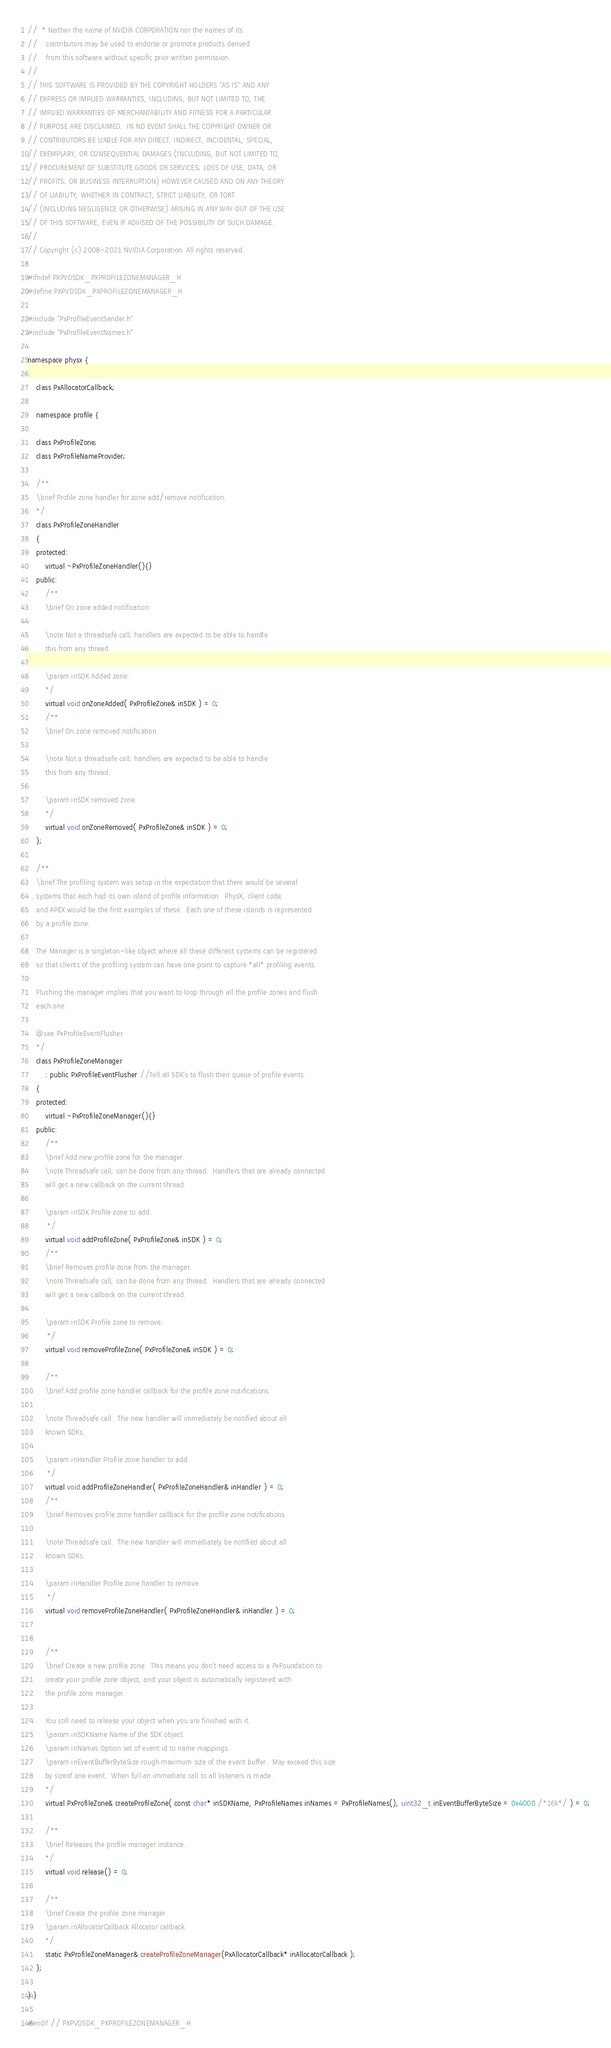<code> <loc_0><loc_0><loc_500><loc_500><_C_>//  * Neither the name of NVIDIA CORPORATION nor the names of its
//    contributors may be used to endorse or promote products derived
//    from this software without specific prior written permission.
//
// THIS SOFTWARE IS PROVIDED BY THE COPYRIGHT HOLDERS ''AS IS'' AND ANY
// EXPRESS OR IMPLIED WARRANTIES, INCLUDING, BUT NOT LIMITED TO, THE
// IMPLIED WARRANTIES OF MERCHANTABILITY AND FITNESS FOR A PARTICULAR
// PURPOSE ARE DISCLAIMED.  IN NO EVENT SHALL THE COPYRIGHT OWNER OR
// CONTRIBUTORS BE LIABLE FOR ANY DIRECT, INDIRECT, INCIDENTAL, SPECIAL,
// EXEMPLARY, OR CONSEQUENTIAL DAMAGES (INCLUDING, BUT NOT LIMITED TO,
// PROCUREMENT OF SUBSTITUTE GOODS OR SERVICES; LOSS OF USE, DATA, OR
// PROFITS; OR BUSINESS INTERRUPTION) HOWEVER CAUSED AND ON ANY THEORY
// OF LIABILITY, WHETHER IN CONTRACT, STRICT LIABILITY, OR TORT
// (INCLUDING NEGLIGENCE OR OTHERWISE) ARISING IN ANY WAY OUT OF THE USE
// OF THIS SOFTWARE, EVEN IF ADVISED OF THE POSSIBILITY OF SUCH DAMAGE.
//
// Copyright (c) 2008-2021 NVIDIA Corporation. All rights reserved.

#ifndef PXPVDSDK_PXPROFILEZONEMANAGER_H
#define PXPVDSDK_PXPROFILEZONEMANAGER_H

#include "PxProfileEventSender.h"
#include "PxProfileEventNames.h"

namespace physx { 
	
	class PxAllocatorCallback;
	
	namespace profile {

	class PxProfileZone;
	class PxProfileNameProvider;	

	/**
	\brief Profile zone handler for zone add/remove notification.
	*/
	class PxProfileZoneHandler
	{
	protected:
		virtual ~PxProfileZoneHandler(){}
	public:
		/**
		\brief On zone added notification		

		\note Not a threadsafe call; handlers are expected to be able to handle
		this from any thread.

		\param inSDK Added zone.
		*/
		virtual void onZoneAdded( PxProfileZone& inSDK ) = 0;
		/**
		\brief On zone removed notification		

		\note Not a threadsafe call; handlers are expected to be able to handle
		this from any thread.

		\param inSDK removed zone.
		*/
		virtual void onZoneRemoved( PxProfileZone& inSDK ) = 0;
	};

	/**
	\brief The profiling system was setup in the expectation that there would be several
	systems that each had its own island of profile information.  PhysX, client code,
	and APEX would be the first examples of these.  Each one of these islands is represented
	by a profile zone.
	 	
	The Manager is a singleton-like object where all these different systems can be registered
	so that clients of the profiling system can have one point to capture *all* profiling events.
	 
	Flushing the manager implies that you want to loop through all the profile zones and flush
	each one.

	@see PxProfileEventFlusher
	*/
	class PxProfileZoneManager 
		: public PxProfileEventFlusher //Tell all SDK's to flush their queue of profile events.
	{
	protected:
		virtual ~PxProfileZoneManager(){}
	public:
		/**
		\brief Add new profile zone for the manager.
		\note Threadsafe call, can be done from any thread.  Handlers that are already connected
		will get a new callback on the current thread.

		\param inSDK Profile zone to add.
		 */
		virtual void addProfileZone( PxProfileZone& inSDK ) = 0;
		/**
		\brief Removes profile zone from the manager.
		\note Threadsafe call, can be done from any thread.  Handlers that are already connected
		will get a new callback on the current thread.

		\param inSDK Profile zone to remove.
		 */
		virtual void removeProfileZone( PxProfileZone& inSDK ) = 0;

		/**
		\brief Add profile zone handler callback for the profile zone notifications.

		\note Threadsafe call.  The new handler will immediately be notified about all
		known SDKs.

		\param inHandler Profile zone handler to add.
		 */
		virtual void addProfileZoneHandler( PxProfileZoneHandler& inHandler ) = 0;
		/**
		\brief Removes profile zone handler callback for the profile zone notifications.

		\note Threadsafe call.  The new handler will immediately be notified about all
		known SDKs.

		\param inHandler Profile zone handler to remove.
		 */
		virtual void removeProfileZoneHandler( PxProfileZoneHandler& inHandler ) = 0;


		/**
		\brief Create a new profile zone.  This means you don't need access to a PxFoundation to 
		create your profile zone object, and your object is automatically registered with
		the profile zone manager.
		
		You still need to release your object when you are finished with it.
		\param inSDKName Name of the SDK object.
		\param inNames Option set of event id to name mappings.
		\param inEventBufferByteSize rough maximum size of the event buffer.  May exceed this size
		by sizeof one event.  When full an immediate call to all listeners is made.
		*/
		virtual PxProfileZone& createProfileZone( const char* inSDKName, PxProfileNames inNames = PxProfileNames(), uint32_t inEventBufferByteSize = 0x4000 /*16k*/ ) = 0;

		/**
		\brief Releases the profile manager instance.
		*/
		virtual void release() = 0;
		
		/**
		\brief Create the profile zone manager.
		\param inAllocatorCallback Allocator callback.
		*/
		static PxProfileZoneManager& createProfileZoneManager(PxAllocatorCallback* inAllocatorCallback );
	};

} }

#endif // PXPVDSDK_PXPROFILEZONEMANAGER_H
</code> 